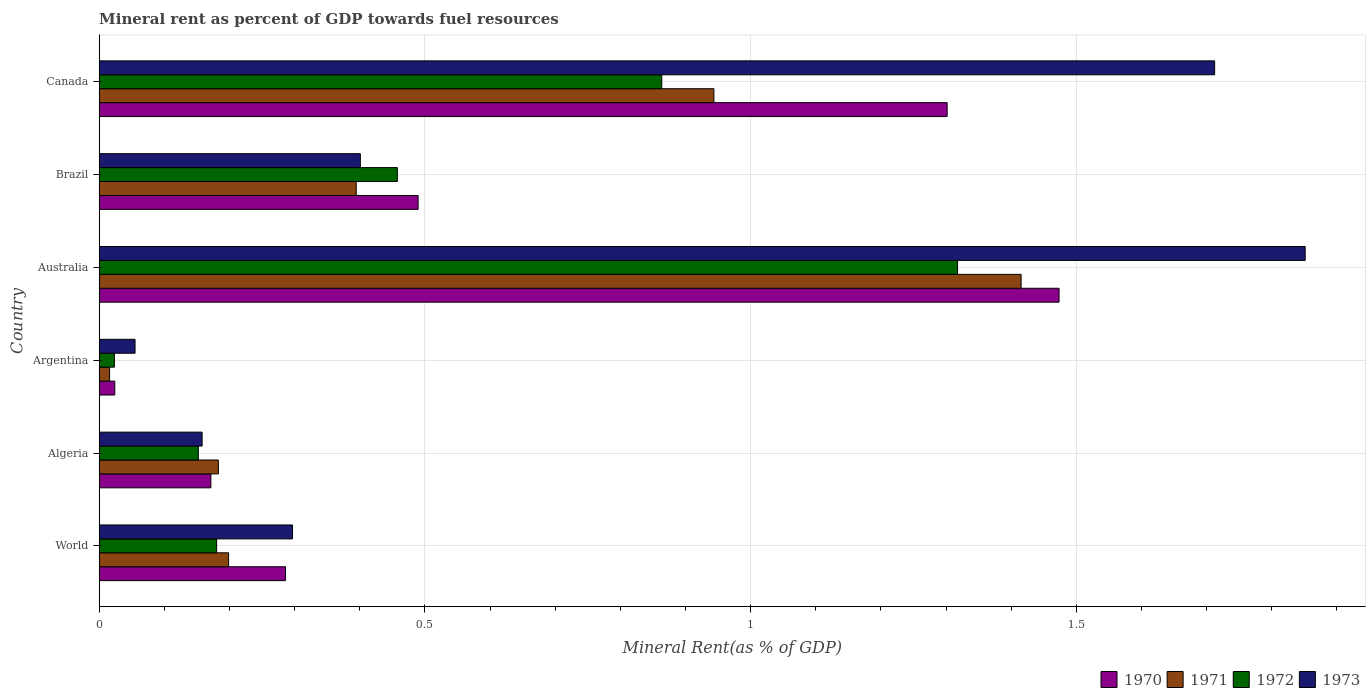How many groups of bars are there?
Make the answer very short. 6. Are the number of bars on each tick of the Y-axis equal?
Make the answer very short. Yes. How many bars are there on the 2nd tick from the top?
Provide a short and direct response. 4. How many bars are there on the 2nd tick from the bottom?
Offer a very short reply. 4. What is the label of the 3rd group of bars from the top?
Make the answer very short. Australia. In how many cases, is the number of bars for a given country not equal to the number of legend labels?
Ensure brevity in your answer.  0. What is the mineral rent in 1973 in World?
Provide a short and direct response. 0.3. Across all countries, what is the maximum mineral rent in 1971?
Keep it short and to the point. 1.42. Across all countries, what is the minimum mineral rent in 1970?
Provide a succinct answer. 0.02. In which country was the mineral rent in 1971 minimum?
Give a very brief answer. Argentina. What is the total mineral rent in 1973 in the graph?
Your answer should be very brief. 4.47. What is the difference between the mineral rent in 1973 in Algeria and that in Brazil?
Keep it short and to the point. -0.24. What is the difference between the mineral rent in 1972 in Brazil and the mineral rent in 1971 in World?
Offer a terse response. 0.26. What is the average mineral rent in 1973 per country?
Offer a very short reply. 0.75. What is the difference between the mineral rent in 1971 and mineral rent in 1973 in Argentina?
Keep it short and to the point. -0.04. In how many countries, is the mineral rent in 1972 greater than 0.9 %?
Give a very brief answer. 1. What is the ratio of the mineral rent in 1972 in Argentina to that in Canada?
Provide a short and direct response. 0.03. Is the mineral rent in 1971 in Australia less than that in World?
Offer a very short reply. No. Is the difference between the mineral rent in 1971 in Argentina and Brazil greater than the difference between the mineral rent in 1973 in Argentina and Brazil?
Your answer should be compact. No. What is the difference between the highest and the second highest mineral rent in 1973?
Keep it short and to the point. 0.14. What is the difference between the highest and the lowest mineral rent in 1971?
Provide a succinct answer. 1.4. Is it the case that in every country, the sum of the mineral rent in 1973 and mineral rent in 1970 is greater than the mineral rent in 1972?
Provide a short and direct response. Yes. How many bars are there?
Your answer should be very brief. 24. Are all the bars in the graph horizontal?
Provide a short and direct response. Yes. How many countries are there in the graph?
Keep it short and to the point. 6. Are the values on the major ticks of X-axis written in scientific E-notation?
Offer a terse response. No. Does the graph contain any zero values?
Your answer should be compact. No. Does the graph contain grids?
Make the answer very short. Yes. Where does the legend appear in the graph?
Your answer should be very brief. Bottom right. How many legend labels are there?
Give a very brief answer. 4. How are the legend labels stacked?
Provide a succinct answer. Horizontal. What is the title of the graph?
Provide a succinct answer. Mineral rent as percent of GDP towards fuel resources. Does "1969" appear as one of the legend labels in the graph?
Keep it short and to the point. No. What is the label or title of the X-axis?
Ensure brevity in your answer.  Mineral Rent(as % of GDP). What is the Mineral Rent(as % of GDP) of 1970 in World?
Make the answer very short. 0.29. What is the Mineral Rent(as % of GDP) of 1971 in World?
Ensure brevity in your answer.  0.2. What is the Mineral Rent(as % of GDP) in 1972 in World?
Ensure brevity in your answer.  0.18. What is the Mineral Rent(as % of GDP) in 1973 in World?
Provide a short and direct response. 0.3. What is the Mineral Rent(as % of GDP) of 1970 in Algeria?
Provide a short and direct response. 0.17. What is the Mineral Rent(as % of GDP) of 1971 in Algeria?
Ensure brevity in your answer.  0.18. What is the Mineral Rent(as % of GDP) in 1972 in Algeria?
Offer a very short reply. 0.15. What is the Mineral Rent(as % of GDP) of 1973 in Algeria?
Provide a succinct answer. 0.16. What is the Mineral Rent(as % of GDP) of 1970 in Argentina?
Give a very brief answer. 0.02. What is the Mineral Rent(as % of GDP) of 1971 in Argentina?
Your response must be concise. 0.02. What is the Mineral Rent(as % of GDP) in 1972 in Argentina?
Provide a succinct answer. 0.02. What is the Mineral Rent(as % of GDP) of 1973 in Argentina?
Give a very brief answer. 0.06. What is the Mineral Rent(as % of GDP) of 1970 in Australia?
Keep it short and to the point. 1.47. What is the Mineral Rent(as % of GDP) in 1971 in Australia?
Your answer should be compact. 1.42. What is the Mineral Rent(as % of GDP) of 1972 in Australia?
Offer a terse response. 1.32. What is the Mineral Rent(as % of GDP) of 1973 in Australia?
Give a very brief answer. 1.85. What is the Mineral Rent(as % of GDP) of 1970 in Brazil?
Provide a short and direct response. 0.49. What is the Mineral Rent(as % of GDP) of 1971 in Brazil?
Keep it short and to the point. 0.39. What is the Mineral Rent(as % of GDP) in 1972 in Brazil?
Your response must be concise. 0.46. What is the Mineral Rent(as % of GDP) of 1973 in Brazil?
Give a very brief answer. 0.4. What is the Mineral Rent(as % of GDP) in 1970 in Canada?
Your answer should be very brief. 1.3. What is the Mineral Rent(as % of GDP) in 1971 in Canada?
Offer a terse response. 0.94. What is the Mineral Rent(as % of GDP) of 1972 in Canada?
Ensure brevity in your answer.  0.86. What is the Mineral Rent(as % of GDP) in 1973 in Canada?
Provide a succinct answer. 1.71. Across all countries, what is the maximum Mineral Rent(as % of GDP) of 1970?
Make the answer very short. 1.47. Across all countries, what is the maximum Mineral Rent(as % of GDP) of 1971?
Provide a succinct answer. 1.42. Across all countries, what is the maximum Mineral Rent(as % of GDP) in 1972?
Provide a succinct answer. 1.32. Across all countries, what is the maximum Mineral Rent(as % of GDP) of 1973?
Your response must be concise. 1.85. Across all countries, what is the minimum Mineral Rent(as % of GDP) of 1970?
Give a very brief answer. 0.02. Across all countries, what is the minimum Mineral Rent(as % of GDP) in 1971?
Keep it short and to the point. 0.02. Across all countries, what is the minimum Mineral Rent(as % of GDP) in 1972?
Your answer should be compact. 0.02. Across all countries, what is the minimum Mineral Rent(as % of GDP) of 1973?
Your answer should be compact. 0.06. What is the total Mineral Rent(as % of GDP) of 1970 in the graph?
Offer a very short reply. 3.75. What is the total Mineral Rent(as % of GDP) of 1971 in the graph?
Provide a short and direct response. 3.15. What is the total Mineral Rent(as % of GDP) in 1972 in the graph?
Give a very brief answer. 2.99. What is the total Mineral Rent(as % of GDP) in 1973 in the graph?
Your answer should be compact. 4.47. What is the difference between the Mineral Rent(as % of GDP) in 1970 in World and that in Algeria?
Give a very brief answer. 0.11. What is the difference between the Mineral Rent(as % of GDP) in 1971 in World and that in Algeria?
Give a very brief answer. 0.02. What is the difference between the Mineral Rent(as % of GDP) in 1972 in World and that in Algeria?
Your answer should be compact. 0.03. What is the difference between the Mineral Rent(as % of GDP) in 1973 in World and that in Algeria?
Offer a terse response. 0.14. What is the difference between the Mineral Rent(as % of GDP) of 1970 in World and that in Argentina?
Your answer should be compact. 0.26. What is the difference between the Mineral Rent(as % of GDP) in 1971 in World and that in Argentina?
Offer a terse response. 0.18. What is the difference between the Mineral Rent(as % of GDP) in 1972 in World and that in Argentina?
Provide a short and direct response. 0.16. What is the difference between the Mineral Rent(as % of GDP) of 1973 in World and that in Argentina?
Keep it short and to the point. 0.24. What is the difference between the Mineral Rent(as % of GDP) in 1970 in World and that in Australia?
Offer a terse response. -1.19. What is the difference between the Mineral Rent(as % of GDP) in 1971 in World and that in Australia?
Offer a very short reply. -1.22. What is the difference between the Mineral Rent(as % of GDP) in 1972 in World and that in Australia?
Your response must be concise. -1.14. What is the difference between the Mineral Rent(as % of GDP) in 1973 in World and that in Australia?
Give a very brief answer. -1.55. What is the difference between the Mineral Rent(as % of GDP) in 1970 in World and that in Brazil?
Provide a succinct answer. -0.2. What is the difference between the Mineral Rent(as % of GDP) in 1971 in World and that in Brazil?
Provide a succinct answer. -0.2. What is the difference between the Mineral Rent(as % of GDP) of 1972 in World and that in Brazil?
Your response must be concise. -0.28. What is the difference between the Mineral Rent(as % of GDP) in 1973 in World and that in Brazil?
Your response must be concise. -0.1. What is the difference between the Mineral Rent(as % of GDP) of 1970 in World and that in Canada?
Keep it short and to the point. -1.02. What is the difference between the Mineral Rent(as % of GDP) of 1971 in World and that in Canada?
Your response must be concise. -0.74. What is the difference between the Mineral Rent(as % of GDP) in 1972 in World and that in Canada?
Provide a succinct answer. -0.68. What is the difference between the Mineral Rent(as % of GDP) in 1973 in World and that in Canada?
Give a very brief answer. -1.42. What is the difference between the Mineral Rent(as % of GDP) of 1970 in Algeria and that in Argentina?
Keep it short and to the point. 0.15. What is the difference between the Mineral Rent(as % of GDP) of 1971 in Algeria and that in Argentina?
Your response must be concise. 0.17. What is the difference between the Mineral Rent(as % of GDP) in 1972 in Algeria and that in Argentina?
Your response must be concise. 0.13. What is the difference between the Mineral Rent(as % of GDP) in 1973 in Algeria and that in Argentina?
Provide a short and direct response. 0.1. What is the difference between the Mineral Rent(as % of GDP) of 1970 in Algeria and that in Australia?
Offer a very short reply. -1.3. What is the difference between the Mineral Rent(as % of GDP) of 1971 in Algeria and that in Australia?
Your answer should be very brief. -1.23. What is the difference between the Mineral Rent(as % of GDP) in 1972 in Algeria and that in Australia?
Your response must be concise. -1.17. What is the difference between the Mineral Rent(as % of GDP) of 1973 in Algeria and that in Australia?
Provide a succinct answer. -1.69. What is the difference between the Mineral Rent(as % of GDP) in 1970 in Algeria and that in Brazil?
Ensure brevity in your answer.  -0.32. What is the difference between the Mineral Rent(as % of GDP) of 1971 in Algeria and that in Brazil?
Ensure brevity in your answer.  -0.21. What is the difference between the Mineral Rent(as % of GDP) of 1972 in Algeria and that in Brazil?
Your response must be concise. -0.31. What is the difference between the Mineral Rent(as % of GDP) in 1973 in Algeria and that in Brazil?
Your response must be concise. -0.24. What is the difference between the Mineral Rent(as % of GDP) in 1970 in Algeria and that in Canada?
Your answer should be compact. -1.13. What is the difference between the Mineral Rent(as % of GDP) in 1971 in Algeria and that in Canada?
Offer a terse response. -0.76. What is the difference between the Mineral Rent(as % of GDP) in 1972 in Algeria and that in Canada?
Your answer should be compact. -0.71. What is the difference between the Mineral Rent(as % of GDP) in 1973 in Algeria and that in Canada?
Make the answer very short. -1.55. What is the difference between the Mineral Rent(as % of GDP) of 1970 in Argentina and that in Australia?
Make the answer very short. -1.45. What is the difference between the Mineral Rent(as % of GDP) of 1971 in Argentina and that in Australia?
Your answer should be compact. -1.4. What is the difference between the Mineral Rent(as % of GDP) of 1972 in Argentina and that in Australia?
Make the answer very short. -1.29. What is the difference between the Mineral Rent(as % of GDP) in 1973 in Argentina and that in Australia?
Provide a succinct answer. -1.8. What is the difference between the Mineral Rent(as % of GDP) of 1970 in Argentina and that in Brazil?
Your answer should be compact. -0.47. What is the difference between the Mineral Rent(as % of GDP) of 1971 in Argentina and that in Brazil?
Provide a succinct answer. -0.38. What is the difference between the Mineral Rent(as % of GDP) of 1972 in Argentina and that in Brazil?
Provide a short and direct response. -0.43. What is the difference between the Mineral Rent(as % of GDP) of 1973 in Argentina and that in Brazil?
Provide a succinct answer. -0.35. What is the difference between the Mineral Rent(as % of GDP) of 1970 in Argentina and that in Canada?
Your response must be concise. -1.28. What is the difference between the Mineral Rent(as % of GDP) in 1971 in Argentina and that in Canada?
Make the answer very short. -0.93. What is the difference between the Mineral Rent(as % of GDP) of 1972 in Argentina and that in Canada?
Your answer should be compact. -0.84. What is the difference between the Mineral Rent(as % of GDP) of 1973 in Argentina and that in Canada?
Your answer should be very brief. -1.66. What is the difference between the Mineral Rent(as % of GDP) in 1971 in Australia and that in Brazil?
Offer a very short reply. 1.02. What is the difference between the Mineral Rent(as % of GDP) of 1972 in Australia and that in Brazil?
Provide a short and direct response. 0.86. What is the difference between the Mineral Rent(as % of GDP) of 1973 in Australia and that in Brazil?
Your response must be concise. 1.45. What is the difference between the Mineral Rent(as % of GDP) of 1970 in Australia and that in Canada?
Keep it short and to the point. 0.17. What is the difference between the Mineral Rent(as % of GDP) in 1971 in Australia and that in Canada?
Ensure brevity in your answer.  0.47. What is the difference between the Mineral Rent(as % of GDP) in 1972 in Australia and that in Canada?
Provide a short and direct response. 0.45. What is the difference between the Mineral Rent(as % of GDP) of 1973 in Australia and that in Canada?
Your answer should be compact. 0.14. What is the difference between the Mineral Rent(as % of GDP) in 1970 in Brazil and that in Canada?
Keep it short and to the point. -0.81. What is the difference between the Mineral Rent(as % of GDP) of 1971 in Brazil and that in Canada?
Ensure brevity in your answer.  -0.55. What is the difference between the Mineral Rent(as % of GDP) in 1972 in Brazil and that in Canada?
Give a very brief answer. -0.41. What is the difference between the Mineral Rent(as % of GDP) of 1973 in Brazil and that in Canada?
Your answer should be very brief. -1.31. What is the difference between the Mineral Rent(as % of GDP) of 1970 in World and the Mineral Rent(as % of GDP) of 1971 in Algeria?
Offer a terse response. 0.1. What is the difference between the Mineral Rent(as % of GDP) of 1970 in World and the Mineral Rent(as % of GDP) of 1972 in Algeria?
Provide a short and direct response. 0.13. What is the difference between the Mineral Rent(as % of GDP) in 1970 in World and the Mineral Rent(as % of GDP) in 1973 in Algeria?
Provide a short and direct response. 0.13. What is the difference between the Mineral Rent(as % of GDP) in 1971 in World and the Mineral Rent(as % of GDP) in 1972 in Algeria?
Your answer should be compact. 0.05. What is the difference between the Mineral Rent(as % of GDP) in 1971 in World and the Mineral Rent(as % of GDP) in 1973 in Algeria?
Offer a very short reply. 0.04. What is the difference between the Mineral Rent(as % of GDP) of 1972 in World and the Mineral Rent(as % of GDP) of 1973 in Algeria?
Ensure brevity in your answer.  0.02. What is the difference between the Mineral Rent(as % of GDP) in 1970 in World and the Mineral Rent(as % of GDP) in 1971 in Argentina?
Make the answer very short. 0.27. What is the difference between the Mineral Rent(as % of GDP) in 1970 in World and the Mineral Rent(as % of GDP) in 1972 in Argentina?
Provide a succinct answer. 0.26. What is the difference between the Mineral Rent(as % of GDP) of 1970 in World and the Mineral Rent(as % of GDP) of 1973 in Argentina?
Ensure brevity in your answer.  0.23. What is the difference between the Mineral Rent(as % of GDP) in 1971 in World and the Mineral Rent(as % of GDP) in 1972 in Argentina?
Ensure brevity in your answer.  0.18. What is the difference between the Mineral Rent(as % of GDP) of 1971 in World and the Mineral Rent(as % of GDP) of 1973 in Argentina?
Ensure brevity in your answer.  0.14. What is the difference between the Mineral Rent(as % of GDP) of 1972 in World and the Mineral Rent(as % of GDP) of 1973 in Argentina?
Make the answer very short. 0.13. What is the difference between the Mineral Rent(as % of GDP) of 1970 in World and the Mineral Rent(as % of GDP) of 1971 in Australia?
Make the answer very short. -1.13. What is the difference between the Mineral Rent(as % of GDP) in 1970 in World and the Mineral Rent(as % of GDP) in 1972 in Australia?
Offer a terse response. -1.03. What is the difference between the Mineral Rent(as % of GDP) in 1970 in World and the Mineral Rent(as % of GDP) in 1973 in Australia?
Give a very brief answer. -1.57. What is the difference between the Mineral Rent(as % of GDP) of 1971 in World and the Mineral Rent(as % of GDP) of 1972 in Australia?
Keep it short and to the point. -1.12. What is the difference between the Mineral Rent(as % of GDP) in 1971 in World and the Mineral Rent(as % of GDP) in 1973 in Australia?
Provide a short and direct response. -1.65. What is the difference between the Mineral Rent(as % of GDP) of 1972 in World and the Mineral Rent(as % of GDP) of 1973 in Australia?
Offer a terse response. -1.67. What is the difference between the Mineral Rent(as % of GDP) in 1970 in World and the Mineral Rent(as % of GDP) in 1971 in Brazil?
Keep it short and to the point. -0.11. What is the difference between the Mineral Rent(as % of GDP) in 1970 in World and the Mineral Rent(as % of GDP) in 1972 in Brazil?
Keep it short and to the point. -0.17. What is the difference between the Mineral Rent(as % of GDP) of 1970 in World and the Mineral Rent(as % of GDP) of 1973 in Brazil?
Give a very brief answer. -0.11. What is the difference between the Mineral Rent(as % of GDP) of 1971 in World and the Mineral Rent(as % of GDP) of 1972 in Brazil?
Keep it short and to the point. -0.26. What is the difference between the Mineral Rent(as % of GDP) in 1971 in World and the Mineral Rent(as % of GDP) in 1973 in Brazil?
Make the answer very short. -0.2. What is the difference between the Mineral Rent(as % of GDP) in 1972 in World and the Mineral Rent(as % of GDP) in 1973 in Brazil?
Give a very brief answer. -0.22. What is the difference between the Mineral Rent(as % of GDP) in 1970 in World and the Mineral Rent(as % of GDP) in 1971 in Canada?
Provide a succinct answer. -0.66. What is the difference between the Mineral Rent(as % of GDP) in 1970 in World and the Mineral Rent(as % of GDP) in 1972 in Canada?
Keep it short and to the point. -0.58. What is the difference between the Mineral Rent(as % of GDP) of 1970 in World and the Mineral Rent(as % of GDP) of 1973 in Canada?
Provide a short and direct response. -1.43. What is the difference between the Mineral Rent(as % of GDP) of 1971 in World and the Mineral Rent(as % of GDP) of 1972 in Canada?
Give a very brief answer. -0.67. What is the difference between the Mineral Rent(as % of GDP) of 1971 in World and the Mineral Rent(as % of GDP) of 1973 in Canada?
Your answer should be very brief. -1.51. What is the difference between the Mineral Rent(as % of GDP) of 1972 in World and the Mineral Rent(as % of GDP) of 1973 in Canada?
Provide a short and direct response. -1.53. What is the difference between the Mineral Rent(as % of GDP) in 1970 in Algeria and the Mineral Rent(as % of GDP) in 1971 in Argentina?
Provide a short and direct response. 0.16. What is the difference between the Mineral Rent(as % of GDP) of 1970 in Algeria and the Mineral Rent(as % of GDP) of 1972 in Argentina?
Your answer should be very brief. 0.15. What is the difference between the Mineral Rent(as % of GDP) of 1970 in Algeria and the Mineral Rent(as % of GDP) of 1973 in Argentina?
Keep it short and to the point. 0.12. What is the difference between the Mineral Rent(as % of GDP) in 1971 in Algeria and the Mineral Rent(as % of GDP) in 1972 in Argentina?
Keep it short and to the point. 0.16. What is the difference between the Mineral Rent(as % of GDP) of 1971 in Algeria and the Mineral Rent(as % of GDP) of 1973 in Argentina?
Give a very brief answer. 0.13. What is the difference between the Mineral Rent(as % of GDP) in 1972 in Algeria and the Mineral Rent(as % of GDP) in 1973 in Argentina?
Offer a terse response. 0.1. What is the difference between the Mineral Rent(as % of GDP) in 1970 in Algeria and the Mineral Rent(as % of GDP) in 1971 in Australia?
Provide a short and direct response. -1.24. What is the difference between the Mineral Rent(as % of GDP) in 1970 in Algeria and the Mineral Rent(as % of GDP) in 1972 in Australia?
Keep it short and to the point. -1.15. What is the difference between the Mineral Rent(as % of GDP) of 1970 in Algeria and the Mineral Rent(as % of GDP) of 1973 in Australia?
Offer a very short reply. -1.68. What is the difference between the Mineral Rent(as % of GDP) in 1971 in Algeria and the Mineral Rent(as % of GDP) in 1972 in Australia?
Make the answer very short. -1.13. What is the difference between the Mineral Rent(as % of GDP) of 1971 in Algeria and the Mineral Rent(as % of GDP) of 1973 in Australia?
Your response must be concise. -1.67. What is the difference between the Mineral Rent(as % of GDP) in 1972 in Algeria and the Mineral Rent(as % of GDP) in 1973 in Australia?
Provide a short and direct response. -1.7. What is the difference between the Mineral Rent(as % of GDP) in 1970 in Algeria and the Mineral Rent(as % of GDP) in 1971 in Brazil?
Your answer should be compact. -0.22. What is the difference between the Mineral Rent(as % of GDP) of 1970 in Algeria and the Mineral Rent(as % of GDP) of 1972 in Brazil?
Provide a succinct answer. -0.29. What is the difference between the Mineral Rent(as % of GDP) in 1970 in Algeria and the Mineral Rent(as % of GDP) in 1973 in Brazil?
Offer a terse response. -0.23. What is the difference between the Mineral Rent(as % of GDP) in 1971 in Algeria and the Mineral Rent(as % of GDP) in 1972 in Brazil?
Offer a terse response. -0.27. What is the difference between the Mineral Rent(as % of GDP) in 1971 in Algeria and the Mineral Rent(as % of GDP) in 1973 in Brazil?
Offer a terse response. -0.22. What is the difference between the Mineral Rent(as % of GDP) of 1972 in Algeria and the Mineral Rent(as % of GDP) of 1973 in Brazil?
Make the answer very short. -0.25. What is the difference between the Mineral Rent(as % of GDP) in 1970 in Algeria and the Mineral Rent(as % of GDP) in 1971 in Canada?
Provide a short and direct response. -0.77. What is the difference between the Mineral Rent(as % of GDP) in 1970 in Algeria and the Mineral Rent(as % of GDP) in 1972 in Canada?
Your answer should be very brief. -0.69. What is the difference between the Mineral Rent(as % of GDP) in 1970 in Algeria and the Mineral Rent(as % of GDP) in 1973 in Canada?
Keep it short and to the point. -1.54. What is the difference between the Mineral Rent(as % of GDP) in 1971 in Algeria and the Mineral Rent(as % of GDP) in 1972 in Canada?
Provide a short and direct response. -0.68. What is the difference between the Mineral Rent(as % of GDP) of 1971 in Algeria and the Mineral Rent(as % of GDP) of 1973 in Canada?
Your answer should be compact. -1.53. What is the difference between the Mineral Rent(as % of GDP) of 1972 in Algeria and the Mineral Rent(as % of GDP) of 1973 in Canada?
Offer a very short reply. -1.56. What is the difference between the Mineral Rent(as % of GDP) of 1970 in Argentina and the Mineral Rent(as % of GDP) of 1971 in Australia?
Offer a terse response. -1.39. What is the difference between the Mineral Rent(as % of GDP) in 1970 in Argentina and the Mineral Rent(as % of GDP) in 1972 in Australia?
Ensure brevity in your answer.  -1.29. What is the difference between the Mineral Rent(as % of GDP) in 1970 in Argentina and the Mineral Rent(as % of GDP) in 1973 in Australia?
Ensure brevity in your answer.  -1.83. What is the difference between the Mineral Rent(as % of GDP) of 1971 in Argentina and the Mineral Rent(as % of GDP) of 1972 in Australia?
Offer a very short reply. -1.3. What is the difference between the Mineral Rent(as % of GDP) of 1971 in Argentina and the Mineral Rent(as % of GDP) of 1973 in Australia?
Your response must be concise. -1.84. What is the difference between the Mineral Rent(as % of GDP) of 1972 in Argentina and the Mineral Rent(as % of GDP) of 1973 in Australia?
Offer a terse response. -1.83. What is the difference between the Mineral Rent(as % of GDP) of 1970 in Argentina and the Mineral Rent(as % of GDP) of 1971 in Brazil?
Ensure brevity in your answer.  -0.37. What is the difference between the Mineral Rent(as % of GDP) in 1970 in Argentina and the Mineral Rent(as % of GDP) in 1972 in Brazil?
Offer a terse response. -0.43. What is the difference between the Mineral Rent(as % of GDP) of 1970 in Argentina and the Mineral Rent(as % of GDP) of 1973 in Brazil?
Your response must be concise. -0.38. What is the difference between the Mineral Rent(as % of GDP) of 1971 in Argentina and the Mineral Rent(as % of GDP) of 1972 in Brazil?
Make the answer very short. -0.44. What is the difference between the Mineral Rent(as % of GDP) of 1971 in Argentina and the Mineral Rent(as % of GDP) of 1973 in Brazil?
Give a very brief answer. -0.39. What is the difference between the Mineral Rent(as % of GDP) of 1972 in Argentina and the Mineral Rent(as % of GDP) of 1973 in Brazil?
Make the answer very short. -0.38. What is the difference between the Mineral Rent(as % of GDP) in 1970 in Argentina and the Mineral Rent(as % of GDP) in 1971 in Canada?
Provide a short and direct response. -0.92. What is the difference between the Mineral Rent(as % of GDP) in 1970 in Argentina and the Mineral Rent(as % of GDP) in 1972 in Canada?
Provide a succinct answer. -0.84. What is the difference between the Mineral Rent(as % of GDP) of 1970 in Argentina and the Mineral Rent(as % of GDP) of 1973 in Canada?
Your answer should be very brief. -1.69. What is the difference between the Mineral Rent(as % of GDP) in 1971 in Argentina and the Mineral Rent(as % of GDP) in 1972 in Canada?
Give a very brief answer. -0.85. What is the difference between the Mineral Rent(as % of GDP) of 1971 in Argentina and the Mineral Rent(as % of GDP) of 1973 in Canada?
Offer a very short reply. -1.7. What is the difference between the Mineral Rent(as % of GDP) of 1972 in Argentina and the Mineral Rent(as % of GDP) of 1973 in Canada?
Your answer should be very brief. -1.69. What is the difference between the Mineral Rent(as % of GDP) of 1970 in Australia and the Mineral Rent(as % of GDP) of 1971 in Brazil?
Give a very brief answer. 1.08. What is the difference between the Mineral Rent(as % of GDP) of 1970 in Australia and the Mineral Rent(as % of GDP) of 1972 in Brazil?
Your response must be concise. 1.02. What is the difference between the Mineral Rent(as % of GDP) in 1970 in Australia and the Mineral Rent(as % of GDP) in 1973 in Brazil?
Ensure brevity in your answer.  1.07. What is the difference between the Mineral Rent(as % of GDP) of 1971 in Australia and the Mineral Rent(as % of GDP) of 1972 in Brazil?
Keep it short and to the point. 0.96. What is the difference between the Mineral Rent(as % of GDP) of 1971 in Australia and the Mineral Rent(as % of GDP) of 1973 in Brazil?
Provide a succinct answer. 1.01. What is the difference between the Mineral Rent(as % of GDP) of 1972 in Australia and the Mineral Rent(as % of GDP) of 1973 in Brazil?
Provide a succinct answer. 0.92. What is the difference between the Mineral Rent(as % of GDP) of 1970 in Australia and the Mineral Rent(as % of GDP) of 1971 in Canada?
Ensure brevity in your answer.  0.53. What is the difference between the Mineral Rent(as % of GDP) in 1970 in Australia and the Mineral Rent(as % of GDP) in 1972 in Canada?
Your answer should be very brief. 0.61. What is the difference between the Mineral Rent(as % of GDP) of 1970 in Australia and the Mineral Rent(as % of GDP) of 1973 in Canada?
Your answer should be compact. -0.24. What is the difference between the Mineral Rent(as % of GDP) in 1971 in Australia and the Mineral Rent(as % of GDP) in 1972 in Canada?
Give a very brief answer. 0.55. What is the difference between the Mineral Rent(as % of GDP) of 1971 in Australia and the Mineral Rent(as % of GDP) of 1973 in Canada?
Offer a very short reply. -0.3. What is the difference between the Mineral Rent(as % of GDP) of 1972 in Australia and the Mineral Rent(as % of GDP) of 1973 in Canada?
Make the answer very short. -0.39. What is the difference between the Mineral Rent(as % of GDP) of 1970 in Brazil and the Mineral Rent(as % of GDP) of 1971 in Canada?
Keep it short and to the point. -0.45. What is the difference between the Mineral Rent(as % of GDP) of 1970 in Brazil and the Mineral Rent(as % of GDP) of 1972 in Canada?
Your answer should be very brief. -0.37. What is the difference between the Mineral Rent(as % of GDP) of 1970 in Brazil and the Mineral Rent(as % of GDP) of 1973 in Canada?
Offer a terse response. -1.22. What is the difference between the Mineral Rent(as % of GDP) in 1971 in Brazil and the Mineral Rent(as % of GDP) in 1972 in Canada?
Offer a terse response. -0.47. What is the difference between the Mineral Rent(as % of GDP) in 1971 in Brazil and the Mineral Rent(as % of GDP) in 1973 in Canada?
Give a very brief answer. -1.32. What is the difference between the Mineral Rent(as % of GDP) in 1972 in Brazil and the Mineral Rent(as % of GDP) in 1973 in Canada?
Provide a succinct answer. -1.25. What is the average Mineral Rent(as % of GDP) in 1970 per country?
Make the answer very short. 0.62. What is the average Mineral Rent(as % of GDP) of 1971 per country?
Provide a succinct answer. 0.53. What is the average Mineral Rent(as % of GDP) in 1972 per country?
Provide a short and direct response. 0.5. What is the average Mineral Rent(as % of GDP) of 1973 per country?
Offer a terse response. 0.75. What is the difference between the Mineral Rent(as % of GDP) of 1970 and Mineral Rent(as % of GDP) of 1971 in World?
Keep it short and to the point. 0.09. What is the difference between the Mineral Rent(as % of GDP) of 1970 and Mineral Rent(as % of GDP) of 1972 in World?
Your response must be concise. 0.11. What is the difference between the Mineral Rent(as % of GDP) of 1970 and Mineral Rent(as % of GDP) of 1973 in World?
Keep it short and to the point. -0.01. What is the difference between the Mineral Rent(as % of GDP) of 1971 and Mineral Rent(as % of GDP) of 1972 in World?
Your answer should be very brief. 0.02. What is the difference between the Mineral Rent(as % of GDP) in 1971 and Mineral Rent(as % of GDP) in 1973 in World?
Your answer should be compact. -0.1. What is the difference between the Mineral Rent(as % of GDP) of 1972 and Mineral Rent(as % of GDP) of 1973 in World?
Your response must be concise. -0.12. What is the difference between the Mineral Rent(as % of GDP) in 1970 and Mineral Rent(as % of GDP) in 1971 in Algeria?
Offer a very short reply. -0.01. What is the difference between the Mineral Rent(as % of GDP) in 1970 and Mineral Rent(as % of GDP) in 1972 in Algeria?
Provide a succinct answer. 0.02. What is the difference between the Mineral Rent(as % of GDP) of 1970 and Mineral Rent(as % of GDP) of 1973 in Algeria?
Offer a very short reply. 0.01. What is the difference between the Mineral Rent(as % of GDP) in 1971 and Mineral Rent(as % of GDP) in 1972 in Algeria?
Your answer should be very brief. 0.03. What is the difference between the Mineral Rent(as % of GDP) in 1971 and Mineral Rent(as % of GDP) in 1973 in Algeria?
Provide a succinct answer. 0.03. What is the difference between the Mineral Rent(as % of GDP) of 1972 and Mineral Rent(as % of GDP) of 1973 in Algeria?
Give a very brief answer. -0.01. What is the difference between the Mineral Rent(as % of GDP) in 1970 and Mineral Rent(as % of GDP) in 1971 in Argentina?
Offer a terse response. 0.01. What is the difference between the Mineral Rent(as % of GDP) of 1970 and Mineral Rent(as % of GDP) of 1972 in Argentina?
Ensure brevity in your answer.  0. What is the difference between the Mineral Rent(as % of GDP) in 1970 and Mineral Rent(as % of GDP) in 1973 in Argentina?
Ensure brevity in your answer.  -0.03. What is the difference between the Mineral Rent(as % of GDP) in 1971 and Mineral Rent(as % of GDP) in 1972 in Argentina?
Provide a succinct answer. -0.01. What is the difference between the Mineral Rent(as % of GDP) of 1971 and Mineral Rent(as % of GDP) of 1973 in Argentina?
Your answer should be compact. -0.04. What is the difference between the Mineral Rent(as % of GDP) in 1972 and Mineral Rent(as % of GDP) in 1973 in Argentina?
Keep it short and to the point. -0.03. What is the difference between the Mineral Rent(as % of GDP) of 1970 and Mineral Rent(as % of GDP) of 1971 in Australia?
Your answer should be very brief. 0.06. What is the difference between the Mineral Rent(as % of GDP) of 1970 and Mineral Rent(as % of GDP) of 1972 in Australia?
Offer a very short reply. 0.16. What is the difference between the Mineral Rent(as % of GDP) of 1970 and Mineral Rent(as % of GDP) of 1973 in Australia?
Offer a very short reply. -0.38. What is the difference between the Mineral Rent(as % of GDP) in 1971 and Mineral Rent(as % of GDP) in 1972 in Australia?
Keep it short and to the point. 0.1. What is the difference between the Mineral Rent(as % of GDP) in 1971 and Mineral Rent(as % of GDP) in 1973 in Australia?
Ensure brevity in your answer.  -0.44. What is the difference between the Mineral Rent(as % of GDP) in 1972 and Mineral Rent(as % of GDP) in 1973 in Australia?
Give a very brief answer. -0.53. What is the difference between the Mineral Rent(as % of GDP) in 1970 and Mineral Rent(as % of GDP) in 1971 in Brazil?
Offer a very short reply. 0.1. What is the difference between the Mineral Rent(as % of GDP) in 1970 and Mineral Rent(as % of GDP) in 1972 in Brazil?
Provide a succinct answer. 0.03. What is the difference between the Mineral Rent(as % of GDP) in 1970 and Mineral Rent(as % of GDP) in 1973 in Brazil?
Offer a very short reply. 0.09. What is the difference between the Mineral Rent(as % of GDP) in 1971 and Mineral Rent(as % of GDP) in 1972 in Brazil?
Offer a terse response. -0.06. What is the difference between the Mineral Rent(as % of GDP) of 1971 and Mineral Rent(as % of GDP) of 1973 in Brazil?
Provide a succinct answer. -0.01. What is the difference between the Mineral Rent(as % of GDP) of 1972 and Mineral Rent(as % of GDP) of 1973 in Brazil?
Your response must be concise. 0.06. What is the difference between the Mineral Rent(as % of GDP) in 1970 and Mineral Rent(as % of GDP) in 1971 in Canada?
Provide a short and direct response. 0.36. What is the difference between the Mineral Rent(as % of GDP) of 1970 and Mineral Rent(as % of GDP) of 1972 in Canada?
Provide a short and direct response. 0.44. What is the difference between the Mineral Rent(as % of GDP) of 1970 and Mineral Rent(as % of GDP) of 1973 in Canada?
Provide a short and direct response. -0.41. What is the difference between the Mineral Rent(as % of GDP) in 1971 and Mineral Rent(as % of GDP) in 1973 in Canada?
Ensure brevity in your answer.  -0.77. What is the difference between the Mineral Rent(as % of GDP) in 1972 and Mineral Rent(as % of GDP) in 1973 in Canada?
Provide a short and direct response. -0.85. What is the ratio of the Mineral Rent(as % of GDP) in 1970 in World to that in Algeria?
Offer a terse response. 1.67. What is the ratio of the Mineral Rent(as % of GDP) of 1971 in World to that in Algeria?
Provide a short and direct response. 1.09. What is the ratio of the Mineral Rent(as % of GDP) in 1972 in World to that in Algeria?
Provide a short and direct response. 1.18. What is the ratio of the Mineral Rent(as % of GDP) of 1973 in World to that in Algeria?
Ensure brevity in your answer.  1.88. What is the ratio of the Mineral Rent(as % of GDP) in 1970 in World to that in Argentina?
Offer a terse response. 11.96. What is the ratio of the Mineral Rent(as % of GDP) of 1971 in World to that in Argentina?
Provide a short and direct response. 12.49. What is the ratio of the Mineral Rent(as % of GDP) in 1972 in World to that in Argentina?
Offer a terse response. 7.73. What is the ratio of the Mineral Rent(as % of GDP) of 1973 in World to that in Argentina?
Offer a very short reply. 5.4. What is the ratio of the Mineral Rent(as % of GDP) of 1970 in World to that in Australia?
Give a very brief answer. 0.19. What is the ratio of the Mineral Rent(as % of GDP) in 1971 in World to that in Australia?
Offer a terse response. 0.14. What is the ratio of the Mineral Rent(as % of GDP) of 1972 in World to that in Australia?
Offer a very short reply. 0.14. What is the ratio of the Mineral Rent(as % of GDP) of 1973 in World to that in Australia?
Offer a terse response. 0.16. What is the ratio of the Mineral Rent(as % of GDP) of 1970 in World to that in Brazil?
Your response must be concise. 0.58. What is the ratio of the Mineral Rent(as % of GDP) in 1971 in World to that in Brazil?
Make the answer very short. 0.5. What is the ratio of the Mineral Rent(as % of GDP) in 1972 in World to that in Brazil?
Keep it short and to the point. 0.39. What is the ratio of the Mineral Rent(as % of GDP) in 1973 in World to that in Brazil?
Provide a short and direct response. 0.74. What is the ratio of the Mineral Rent(as % of GDP) of 1970 in World to that in Canada?
Give a very brief answer. 0.22. What is the ratio of the Mineral Rent(as % of GDP) in 1971 in World to that in Canada?
Provide a succinct answer. 0.21. What is the ratio of the Mineral Rent(as % of GDP) in 1972 in World to that in Canada?
Your answer should be compact. 0.21. What is the ratio of the Mineral Rent(as % of GDP) in 1973 in World to that in Canada?
Offer a very short reply. 0.17. What is the ratio of the Mineral Rent(as % of GDP) of 1970 in Algeria to that in Argentina?
Offer a terse response. 7.17. What is the ratio of the Mineral Rent(as % of GDP) of 1971 in Algeria to that in Argentina?
Your response must be concise. 11.5. What is the ratio of the Mineral Rent(as % of GDP) in 1972 in Algeria to that in Argentina?
Offer a very short reply. 6.53. What is the ratio of the Mineral Rent(as % of GDP) of 1973 in Algeria to that in Argentina?
Your answer should be very brief. 2.87. What is the ratio of the Mineral Rent(as % of GDP) of 1970 in Algeria to that in Australia?
Offer a very short reply. 0.12. What is the ratio of the Mineral Rent(as % of GDP) of 1971 in Algeria to that in Australia?
Provide a succinct answer. 0.13. What is the ratio of the Mineral Rent(as % of GDP) of 1972 in Algeria to that in Australia?
Provide a short and direct response. 0.12. What is the ratio of the Mineral Rent(as % of GDP) in 1973 in Algeria to that in Australia?
Your response must be concise. 0.09. What is the ratio of the Mineral Rent(as % of GDP) of 1970 in Algeria to that in Brazil?
Your answer should be very brief. 0.35. What is the ratio of the Mineral Rent(as % of GDP) of 1971 in Algeria to that in Brazil?
Your answer should be very brief. 0.46. What is the ratio of the Mineral Rent(as % of GDP) of 1972 in Algeria to that in Brazil?
Offer a terse response. 0.33. What is the ratio of the Mineral Rent(as % of GDP) of 1973 in Algeria to that in Brazil?
Your answer should be very brief. 0.39. What is the ratio of the Mineral Rent(as % of GDP) of 1970 in Algeria to that in Canada?
Your response must be concise. 0.13. What is the ratio of the Mineral Rent(as % of GDP) in 1971 in Algeria to that in Canada?
Offer a very short reply. 0.19. What is the ratio of the Mineral Rent(as % of GDP) of 1972 in Algeria to that in Canada?
Offer a very short reply. 0.18. What is the ratio of the Mineral Rent(as % of GDP) in 1973 in Algeria to that in Canada?
Your response must be concise. 0.09. What is the ratio of the Mineral Rent(as % of GDP) in 1970 in Argentina to that in Australia?
Your answer should be compact. 0.02. What is the ratio of the Mineral Rent(as % of GDP) in 1971 in Argentina to that in Australia?
Provide a succinct answer. 0.01. What is the ratio of the Mineral Rent(as % of GDP) in 1972 in Argentina to that in Australia?
Offer a very short reply. 0.02. What is the ratio of the Mineral Rent(as % of GDP) in 1973 in Argentina to that in Australia?
Make the answer very short. 0.03. What is the ratio of the Mineral Rent(as % of GDP) of 1970 in Argentina to that in Brazil?
Ensure brevity in your answer.  0.05. What is the ratio of the Mineral Rent(as % of GDP) of 1971 in Argentina to that in Brazil?
Make the answer very short. 0.04. What is the ratio of the Mineral Rent(as % of GDP) of 1972 in Argentina to that in Brazil?
Your response must be concise. 0.05. What is the ratio of the Mineral Rent(as % of GDP) in 1973 in Argentina to that in Brazil?
Offer a terse response. 0.14. What is the ratio of the Mineral Rent(as % of GDP) in 1970 in Argentina to that in Canada?
Give a very brief answer. 0.02. What is the ratio of the Mineral Rent(as % of GDP) in 1971 in Argentina to that in Canada?
Ensure brevity in your answer.  0.02. What is the ratio of the Mineral Rent(as % of GDP) of 1972 in Argentina to that in Canada?
Give a very brief answer. 0.03. What is the ratio of the Mineral Rent(as % of GDP) in 1973 in Argentina to that in Canada?
Keep it short and to the point. 0.03. What is the ratio of the Mineral Rent(as % of GDP) in 1970 in Australia to that in Brazil?
Your answer should be very brief. 3.01. What is the ratio of the Mineral Rent(as % of GDP) of 1971 in Australia to that in Brazil?
Your response must be concise. 3.59. What is the ratio of the Mineral Rent(as % of GDP) of 1972 in Australia to that in Brazil?
Offer a terse response. 2.88. What is the ratio of the Mineral Rent(as % of GDP) of 1973 in Australia to that in Brazil?
Your response must be concise. 4.62. What is the ratio of the Mineral Rent(as % of GDP) in 1970 in Australia to that in Canada?
Your answer should be compact. 1.13. What is the ratio of the Mineral Rent(as % of GDP) of 1971 in Australia to that in Canada?
Your answer should be compact. 1.5. What is the ratio of the Mineral Rent(as % of GDP) of 1972 in Australia to that in Canada?
Provide a short and direct response. 1.53. What is the ratio of the Mineral Rent(as % of GDP) of 1973 in Australia to that in Canada?
Keep it short and to the point. 1.08. What is the ratio of the Mineral Rent(as % of GDP) of 1970 in Brazil to that in Canada?
Give a very brief answer. 0.38. What is the ratio of the Mineral Rent(as % of GDP) in 1971 in Brazil to that in Canada?
Make the answer very short. 0.42. What is the ratio of the Mineral Rent(as % of GDP) in 1972 in Brazil to that in Canada?
Give a very brief answer. 0.53. What is the ratio of the Mineral Rent(as % of GDP) of 1973 in Brazil to that in Canada?
Provide a succinct answer. 0.23. What is the difference between the highest and the second highest Mineral Rent(as % of GDP) of 1970?
Offer a very short reply. 0.17. What is the difference between the highest and the second highest Mineral Rent(as % of GDP) in 1971?
Make the answer very short. 0.47. What is the difference between the highest and the second highest Mineral Rent(as % of GDP) in 1972?
Your answer should be very brief. 0.45. What is the difference between the highest and the second highest Mineral Rent(as % of GDP) in 1973?
Give a very brief answer. 0.14. What is the difference between the highest and the lowest Mineral Rent(as % of GDP) of 1970?
Ensure brevity in your answer.  1.45. What is the difference between the highest and the lowest Mineral Rent(as % of GDP) of 1971?
Your answer should be very brief. 1.4. What is the difference between the highest and the lowest Mineral Rent(as % of GDP) of 1972?
Keep it short and to the point. 1.29. What is the difference between the highest and the lowest Mineral Rent(as % of GDP) of 1973?
Offer a terse response. 1.8. 